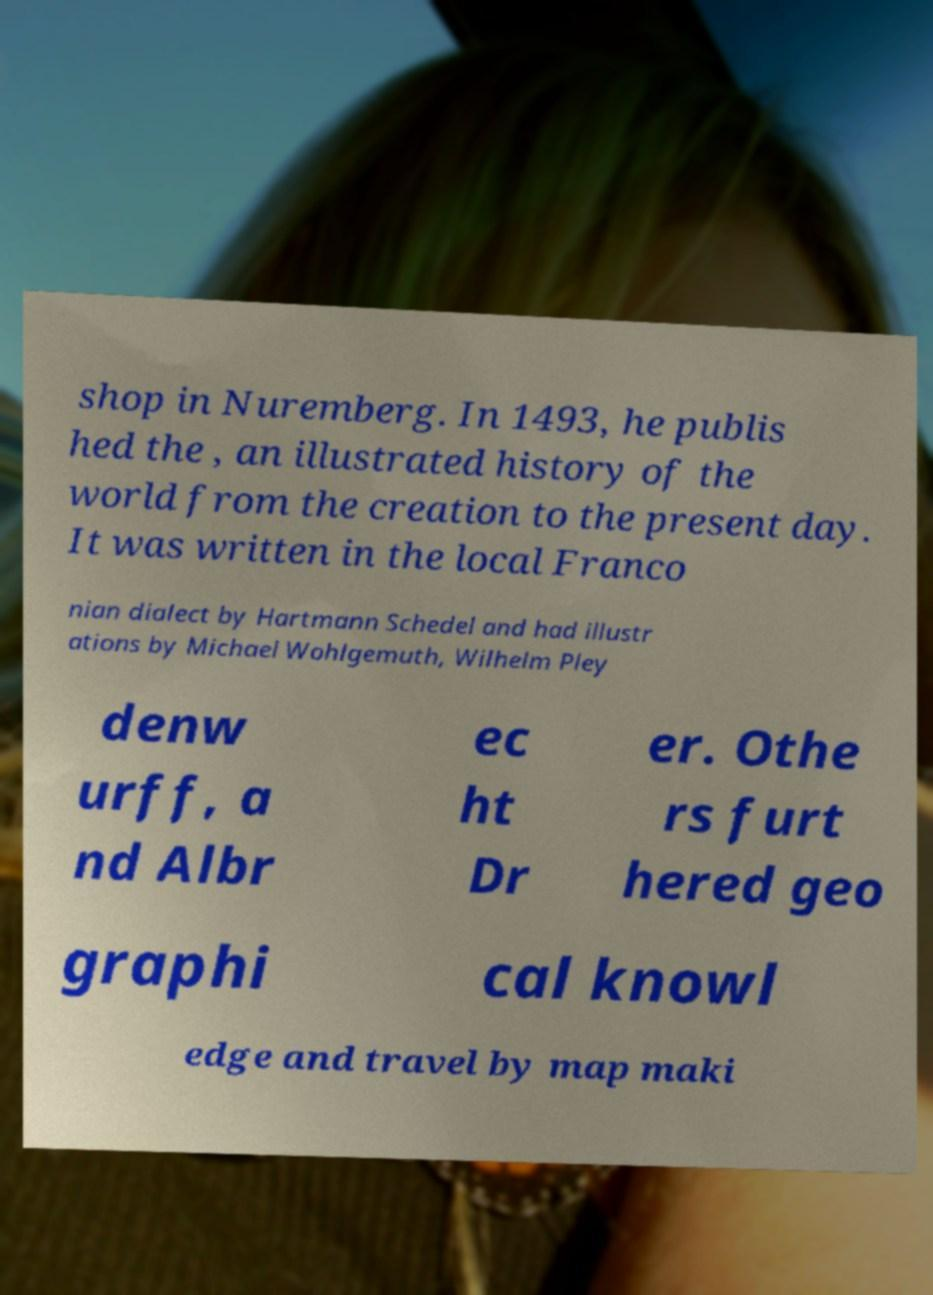I need the written content from this picture converted into text. Can you do that? shop in Nuremberg. In 1493, he publis hed the , an illustrated history of the world from the creation to the present day. It was written in the local Franco nian dialect by Hartmann Schedel and had illustr ations by Michael Wohlgemuth, Wilhelm Pley denw urff, a nd Albr ec ht Dr er. Othe rs furt hered geo graphi cal knowl edge and travel by map maki 